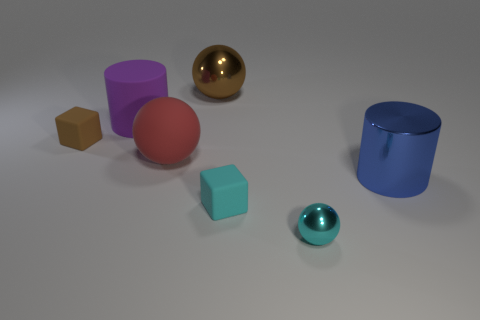Add 3 blue rubber cubes. How many objects exist? 10 Subtract all balls. How many objects are left? 4 Subtract 0 gray spheres. How many objects are left? 7 Subtract all cylinders. Subtract all big shiny spheres. How many objects are left? 4 Add 2 big brown shiny spheres. How many big brown shiny spheres are left? 3 Add 7 cyan rubber things. How many cyan rubber things exist? 8 